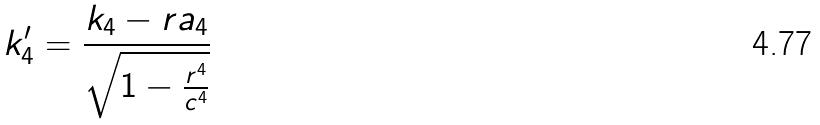Convert formula to latex. <formula><loc_0><loc_0><loc_500><loc_500>k _ { 4 } ^ { \prime } = \frac { k _ { 4 } - r a _ { 4 } } { \sqrt { 1 - \frac { r ^ { 4 } } { c ^ { 4 } } } }</formula> 